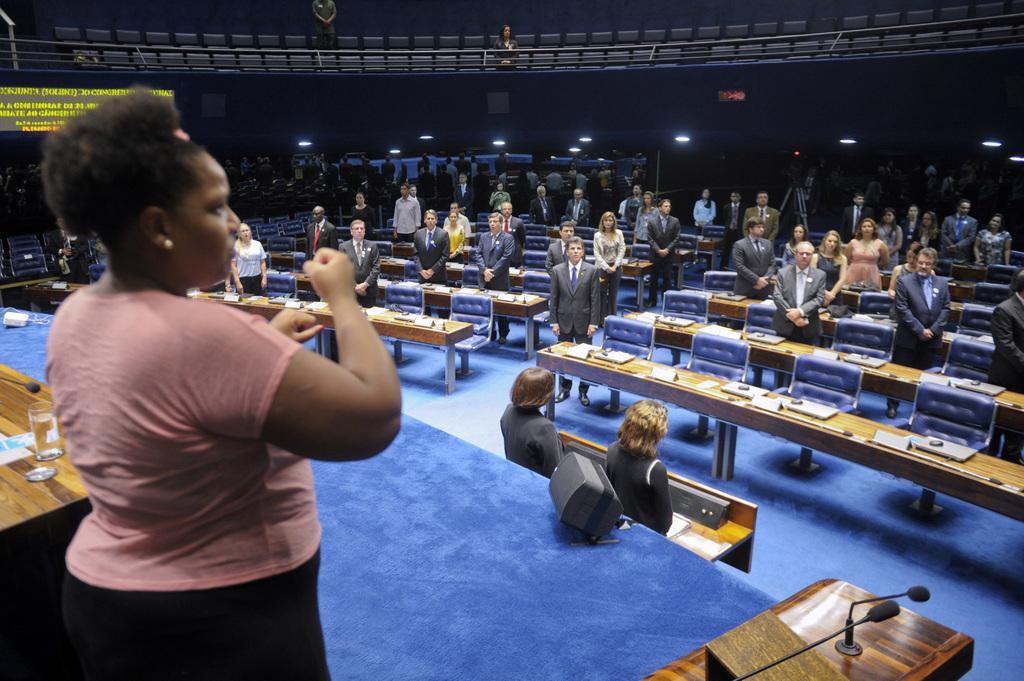Please provide a concise description of this image. There is a lady standing. Near to her there is a table. On the table there is a glass and a mic. This is a stage with blue carpet. On the stage there are speakers. There are many persons standing. There are many tables and chairs. In the background there are lights. and there is a banner with yellow color written over there. 